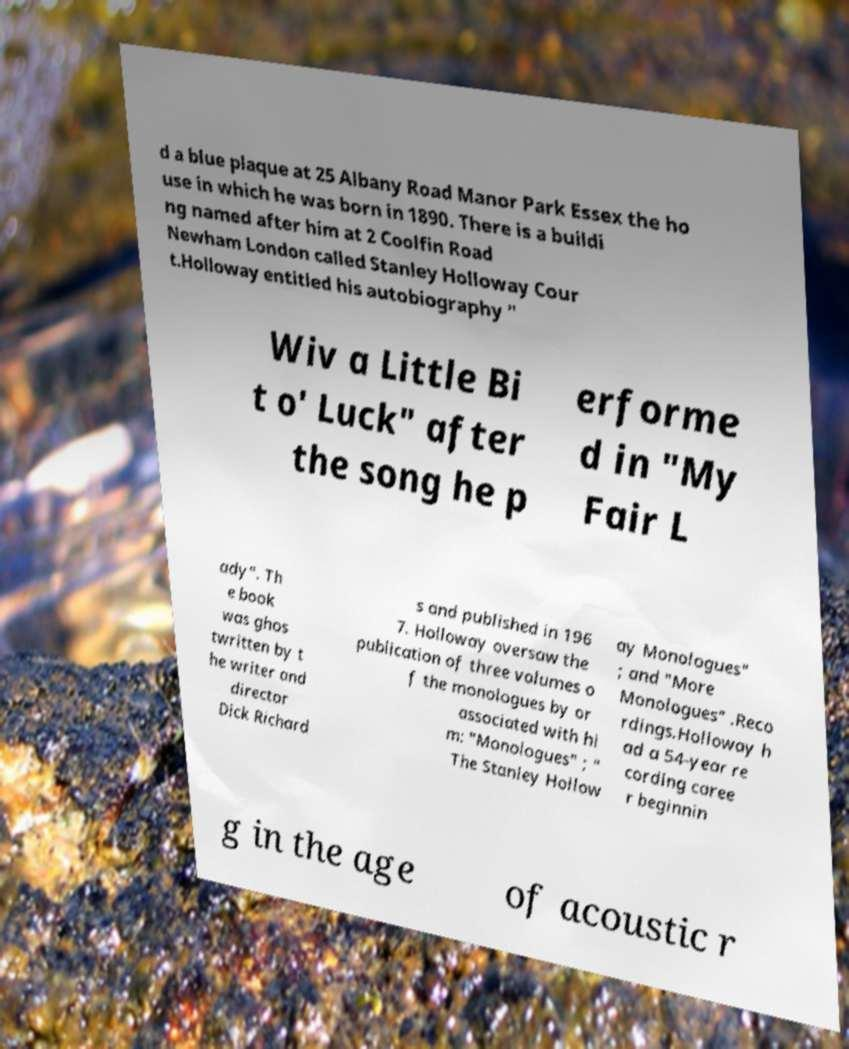Please identify and transcribe the text found in this image. d a blue plaque at 25 Albany Road Manor Park Essex the ho use in which he was born in 1890. There is a buildi ng named after him at 2 Coolfin Road Newham London called Stanley Holloway Cour t.Holloway entitled his autobiography " Wiv a Little Bi t o' Luck" after the song he p erforme d in "My Fair L ady". Th e book was ghos twritten by t he writer and director Dick Richard s and published in 196 7. Holloway oversaw the publication of three volumes o f the monologues by or associated with hi m: "Monologues" ; " The Stanley Hollow ay Monologues" ; and "More Monologues" .Reco rdings.Holloway h ad a 54-year re cording caree r beginnin g in the age of acoustic r 